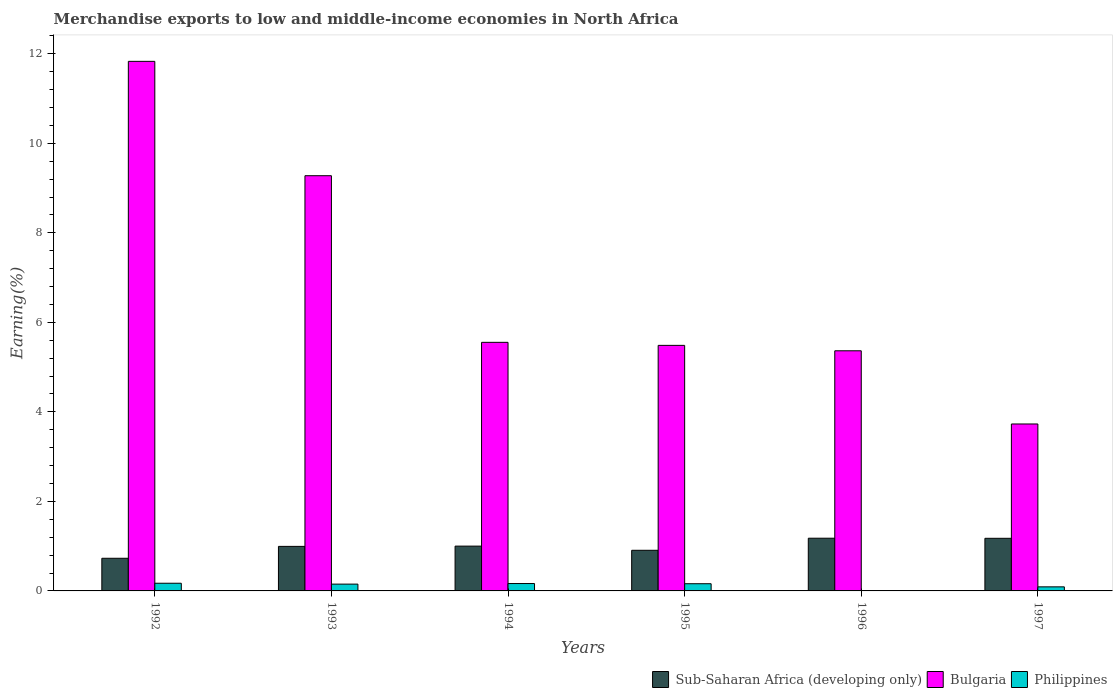How many different coloured bars are there?
Make the answer very short. 3. Are the number of bars on each tick of the X-axis equal?
Provide a short and direct response. Yes. What is the percentage of amount earned from merchandise exports in Bulgaria in 1996?
Offer a terse response. 5.36. Across all years, what is the maximum percentage of amount earned from merchandise exports in Bulgaria?
Your response must be concise. 11.83. Across all years, what is the minimum percentage of amount earned from merchandise exports in Sub-Saharan Africa (developing only)?
Offer a very short reply. 0.73. In which year was the percentage of amount earned from merchandise exports in Sub-Saharan Africa (developing only) maximum?
Your answer should be compact. 1996. In which year was the percentage of amount earned from merchandise exports in Bulgaria minimum?
Your response must be concise. 1997. What is the total percentage of amount earned from merchandise exports in Philippines in the graph?
Provide a succinct answer. 0.75. What is the difference between the percentage of amount earned from merchandise exports in Sub-Saharan Africa (developing only) in 1995 and that in 1997?
Give a very brief answer. -0.27. What is the difference between the percentage of amount earned from merchandise exports in Sub-Saharan Africa (developing only) in 1994 and the percentage of amount earned from merchandise exports in Philippines in 1995?
Provide a short and direct response. 0.84. What is the average percentage of amount earned from merchandise exports in Bulgaria per year?
Provide a succinct answer. 6.87. In the year 1996, what is the difference between the percentage of amount earned from merchandise exports in Sub-Saharan Africa (developing only) and percentage of amount earned from merchandise exports in Philippines?
Provide a short and direct response. 1.17. What is the ratio of the percentage of amount earned from merchandise exports in Philippines in 1992 to that in 1994?
Offer a very short reply. 1.04. Is the percentage of amount earned from merchandise exports in Bulgaria in 1992 less than that in 1995?
Your answer should be very brief. No. Is the difference between the percentage of amount earned from merchandise exports in Sub-Saharan Africa (developing only) in 1993 and 1995 greater than the difference between the percentage of amount earned from merchandise exports in Philippines in 1993 and 1995?
Offer a very short reply. Yes. What is the difference between the highest and the second highest percentage of amount earned from merchandise exports in Bulgaria?
Offer a very short reply. 2.55. What is the difference between the highest and the lowest percentage of amount earned from merchandise exports in Bulgaria?
Your answer should be compact. 8.1. Is the sum of the percentage of amount earned from merchandise exports in Philippines in 1996 and 1997 greater than the maximum percentage of amount earned from merchandise exports in Sub-Saharan Africa (developing only) across all years?
Keep it short and to the point. No. What does the 1st bar from the left in 1995 represents?
Ensure brevity in your answer.  Sub-Saharan Africa (developing only). What does the 3rd bar from the right in 1992 represents?
Provide a short and direct response. Sub-Saharan Africa (developing only). Is it the case that in every year, the sum of the percentage of amount earned from merchandise exports in Philippines and percentage of amount earned from merchandise exports in Bulgaria is greater than the percentage of amount earned from merchandise exports in Sub-Saharan Africa (developing only)?
Provide a short and direct response. Yes. How many bars are there?
Offer a terse response. 18. Are all the bars in the graph horizontal?
Offer a very short reply. No. What is the difference between two consecutive major ticks on the Y-axis?
Your answer should be compact. 2. Does the graph contain grids?
Your response must be concise. No. How are the legend labels stacked?
Offer a terse response. Horizontal. What is the title of the graph?
Your answer should be very brief. Merchandise exports to low and middle-income economies in North Africa. What is the label or title of the Y-axis?
Keep it short and to the point. Earning(%). What is the Earning(%) of Sub-Saharan Africa (developing only) in 1992?
Offer a terse response. 0.73. What is the Earning(%) of Bulgaria in 1992?
Your response must be concise. 11.83. What is the Earning(%) in Philippines in 1992?
Your response must be concise. 0.17. What is the Earning(%) of Sub-Saharan Africa (developing only) in 1993?
Give a very brief answer. 1. What is the Earning(%) of Bulgaria in 1993?
Offer a very short reply. 9.28. What is the Earning(%) of Philippines in 1993?
Your answer should be very brief. 0.15. What is the Earning(%) of Sub-Saharan Africa (developing only) in 1994?
Ensure brevity in your answer.  1. What is the Earning(%) of Bulgaria in 1994?
Your response must be concise. 5.55. What is the Earning(%) of Philippines in 1994?
Give a very brief answer. 0.16. What is the Earning(%) of Sub-Saharan Africa (developing only) in 1995?
Give a very brief answer. 0.91. What is the Earning(%) in Bulgaria in 1995?
Keep it short and to the point. 5.49. What is the Earning(%) in Philippines in 1995?
Your response must be concise. 0.16. What is the Earning(%) of Sub-Saharan Africa (developing only) in 1996?
Ensure brevity in your answer.  1.18. What is the Earning(%) of Bulgaria in 1996?
Your response must be concise. 5.36. What is the Earning(%) in Philippines in 1996?
Your answer should be very brief. 0. What is the Earning(%) in Sub-Saharan Africa (developing only) in 1997?
Make the answer very short. 1.18. What is the Earning(%) of Bulgaria in 1997?
Keep it short and to the point. 3.73. What is the Earning(%) in Philippines in 1997?
Give a very brief answer. 0.09. Across all years, what is the maximum Earning(%) of Sub-Saharan Africa (developing only)?
Provide a short and direct response. 1.18. Across all years, what is the maximum Earning(%) in Bulgaria?
Provide a succinct answer. 11.83. Across all years, what is the maximum Earning(%) in Philippines?
Your answer should be compact. 0.17. Across all years, what is the minimum Earning(%) in Sub-Saharan Africa (developing only)?
Offer a very short reply. 0.73. Across all years, what is the minimum Earning(%) of Bulgaria?
Make the answer very short. 3.73. Across all years, what is the minimum Earning(%) of Philippines?
Provide a succinct answer. 0. What is the total Earning(%) of Sub-Saharan Africa (developing only) in the graph?
Your answer should be very brief. 5.99. What is the total Earning(%) in Bulgaria in the graph?
Your response must be concise. 41.24. What is the total Earning(%) of Philippines in the graph?
Provide a short and direct response. 0.74. What is the difference between the Earning(%) in Sub-Saharan Africa (developing only) in 1992 and that in 1993?
Your answer should be very brief. -0.27. What is the difference between the Earning(%) of Bulgaria in 1992 and that in 1993?
Provide a short and direct response. 2.55. What is the difference between the Earning(%) in Philippines in 1992 and that in 1993?
Provide a short and direct response. 0.02. What is the difference between the Earning(%) in Sub-Saharan Africa (developing only) in 1992 and that in 1994?
Offer a very short reply. -0.27. What is the difference between the Earning(%) in Bulgaria in 1992 and that in 1994?
Make the answer very short. 6.28. What is the difference between the Earning(%) in Philippines in 1992 and that in 1994?
Make the answer very short. 0.01. What is the difference between the Earning(%) of Sub-Saharan Africa (developing only) in 1992 and that in 1995?
Keep it short and to the point. -0.18. What is the difference between the Earning(%) of Bulgaria in 1992 and that in 1995?
Keep it short and to the point. 6.35. What is the difference between the Earning(%) of Philippines in 1992 and that in 1995?
Your response must be concise. 0.01. What is the difference between the Earning(%) of Sub-Saharan Africa (developing only) in 1992 and that in 1996?
Provide a succinct answer. -0.45. What is the difference between the Earning(%) of Bulgaria in 1992 and that in 1996?
Offer a terse response. 6.47. What is the difference between the Earning(%) of Philippines in 1992 and that in 1996?
Keep it short and to the point. 0.17. What is the difference between the Earning(%) in Sub-Saharan Africa (developing only) in 1992 and that in 1997?
Your response must be concise. -0.45. What is the difference between the Earning(%) of Bulgaria in 1992 and that in 1997?
Provide a short and direct response. 8.1. What is the difference between the Earning(%) of Philippines in 1992 and that in 1997?
Your answer should be very brief. 0.08. What is the difference between the Earning(%) in Sub-Saharan Africa (developing only) in 1993 and that in 1994?
Offer a terse response. -0.01. What is the difference between the Earning(%) of Bulgaria in 1993 and that in 1994?
Give a very brief answer. 3.72. What is the difference between the Earning(%) of Philippines in 1993 and that in 1994?
Keep it short and to the point. -0.01. What is the difference between the Earning(%) in Sub-Saharan Africa (developing only) in 1993 and that in 1995?
Your answer should be very brief. 0.09. What is the difference between the Earning(%) of Bulgaria in 1993 and that in 1995?
Give a very brief answer. 3.79. What is the difference between the Earning(%) of Philippines in 1993 and that in 1995?
Ensure brevity in your answer.  -0.01. What is the difference between the Earning(%) in Sub-Saharan Africa (developing only) in 1993 and that in 1996?
Your answer should be very brief. -0.18. What is the difference between the Earning(%) in Bulgaria in 1993 and that in 1996?
Keep it short and to the point. 3.91. What is the difference between the Earning(%) of Philippines in 1993 and that in 1996?
Offer a very short reply. 0.15. What is the difference between the Earning(%) in Sub-Saharan Africa (developing only) in 1993 and that in 1997?
Your answer should be very brief. -0.18. What is the difference between the Earning(%) in Bulgaria in 1993 and that in 1997?
Ensure brevity in your answer.  5.55. What is the difference between the Earning(%) of Philippines in 1993 and that in 1997?
Your response must be concise. 0.06. What is the difference between the Earning(%) of Sub-Saharan Africa (developing only) in 1994 and that in 1995?
Provide a succinct answer. 0.09. What is the difference between the Earning(%) of Bulgaria in 1994 and that in 1995?
Make the answer very short. 0.07. What is the difference between the Earning(%) of Philippines in 1994 and that in 1995?
Ensure brevity in your answer.  0. What is the difference between the Earning(%) of Sub-Saharan Africa (developing only) in 1994 and that in 1996?
Your response must be concise. -0.18. What is the difference between the Earning(%) of Bulgaria in 1994 and that in 1996?
Your response must be concise. 0.19. What is the difference between the Earning(%) of Philippines in 1994 and that in 1996?
Provide a succinct answer. 0.16. What is the difference between the Earning(%) of Sub-Saharan Africa (developing only) in 1994 and that in 1997?
Give a very brief answer. -0.17. What is the difference between the Earning(%) of Bulgaria in 1994 and that in 1997?
Keep it short and to the point. 1.82. What is the difference between the Earning(%) in Philippines in 1994 and that in 1997?
Your response must be concise. 0.07. What is the difference between the Earning(%) in Sub-Saharan Africa (developing only) in 1995 and that in 1996?
Keep it short and to the point. -0.27. What is the difference between the Earning(%) in Bulgaria in 1995 and that in 1996?
Your answer should be very brief. 0.12. What is the difference between the Earning(%) of Philippines in 1995 and that in 1996?
Offer a terse response. 0.16. What is the difference between the Earning(%) of Sub-Saharan Africa (developing only) in 1995 and that in 1997?
Offer a terse response. -0.27. What is the difference between the Earning(%) in Bulgaria in 1995 and that in 1997?
Make the answer very short. 1.76. What is the difference between the Earning(%) of Philippines in 1995 and that in 1997?
Keep it short and to the point. 0.07. What is the difference between the Earning(%) in Sub-Saharan Africa (developing only) in 1996 and that in 1997?
Ensure brevity in your answer.  0. What is the difference between the Earning(%) in Bulgaria in 1996 and that in 1997?
Your response must be concise. 1.64. What is the difference between the Earning(%) in Philippines in 1996 and that in 1997?
Ensure brevity in your answer.  -0.09. What is the difference between the Earning(%) in Sub-Saharan Africa (developing only) in 1992 and the Earning(%) in Bulgaria in 1993?
Keep it short and to the point. -8.55. What is the difference between the Earning(%) in Sub-Saharan Africa (developing only) in 1992 and the Earning(%) in Philippines in 1993?
Your answer should be compact. 0.58. What is the difference between the Earning(%) in Bulgaria in 1992 and the Earning(%) in Philippines in 1993?
Your response must be concise. 11.68. What is the difference between the Earning(%) in Sub-Saharan Africa (developing only) in 1992 and the Earning(%) in Bulgaria in 1994?
Your answer should be compact. -4.82. What is the difference between the Earning(%) in Sub-Saharan Africa (developing only) in 1992 and the Earning(%) in Philippines in 1994?
Make the answer very short. 0.56. What is the difference between the Earning(%) of Bulgaria in 1992 and the Earning(%) of Philippines in 1994?
Ensure brevity in your answer.  11.67. What is the difference between the Earning(%) of Sub-Saharan Africa (developing only) in 1992 and the Earning(%) of Bulgaria in 1995?
Offer a very short reply. -4.76. What is the difference between the Earning(%) of Sub-Saharan Africa (developing only) in 1992 and the Earning(%) of Philippines in 1995?
Give a very brief answer. 0.57. What is the difference between the Earning(%) in Bulgaria in 1992 and the Earning(%) in Philippines in 1995?
Provide a succinct answer. 11.67. What is the difference between the Earning(%) of Sub-Saharan Africa (developing only) in 1992 and the Earning(%) of Bulgaria in 1996?
Offer a terse response. -4.64. What is the difference between the Earning(%) of Sub-Saharan Africa (developing only) in 1992 and the Earning(%) of Philippines in 1996?
Make the answer very short. 0.72. What is the difference between the Earning(%) of Bulgaria in 1992 and the Earning(%) of Philippines in 1996?
Your answer should be very brief. 11.83. What is the difference between the Earning(%) of Sub-Saharan Africa (developing only) in 1992 and the Earning(%) of Bulgaria in 1997?
Give a very brief answer. -3. What is the difference between the Earning(%) of Sub-Saharan Africa (developing only) in 1992 and the Earning(%) of Philippines in 1997?
Your response must be concise. 0.64. What is the difference between the Earning(%) in Bulgaria in 1992 and the Earning(%) in Philippines in 1997?
Provide a short and direct response. 11.74. What is the difference between the Earning(%) in Sub-Saharan Africa (developing only) in 1993 and the Earning(%) in Bulgaria in 1994?
Make the answer very short. -4.56. What is the difference between the Earning(%) of Sub-Saharan Africa (developing only) in 1993 and the Earning(%) of Philippines in 1994?
Ensure brevity in your answer.  0.83. What is the difference between the Earning(%) in Bulgaria in 1993 and the Earning(%) in Philippines in 1994?
Give a very brief answer. 9.11. What is the difference between the Earning(%) in Sub-Saharan Africa (developing only) in 1993 and the Earning(%) in Bulgaria in 1995?
Provide a succinct answer. -4.49. What is the difference between the Earning(%) in Sub-Saharan Africa (developing only) in 1993 and the Earning(%) in Philippines in 1995?
Provide a short and direct response. 0.83. What is the difference between the Earning(%) of Bulgaria in 1993 and the Earning(%) of Philippines in 1995?
Your answer should be compact. 9.12. What is the difference between the Earning(%) of Sub-Saharan Africa (developing only) in 1993 and the Earning(%) of Bulgaria in 1996?
Offer a very short reply. -4.37. What is the difference between the Earning(%) of Sub-Saharan Africa (developing only) in 1993 and the Earning(%) of Philippines in 1996?
Offer a terse response. 0.99. What is the difference between the Earning(%) in Bulgaria in 1993 and the Earning(%) in Philippines in 1996?
Provide a succinct answer. 9.27. What is the difference between the Earning(%) of Sub-Saharan Africa (developing only) in 1993 and the Earning(%) of Bulgaria in 1997?
Make the answer very short. -2.73. What is the difference between the Earning(%) of Sub-Saharan Africa (developing only) in 1993 and the Earning(%) of Philippines in 1997?
Keep it short and to the point. 0.9. What is the difference between the Earning(%) of Bulgaria in 1993 and the Earning(%) of Philippines in 1997?
Your answer should be compact. 9.19. What is the difference between the Earning(%) in Sub-Saharan Africa (developing only) in 1994 and the Earning(%) in Bulgaria in 1995?
Your answer should be very brief. -4.49. What is the difference between the Earning(%) of Sub-Saharan Africa (developing only) in 1994 and the Earning(%) of Philippines in 1995?
Offer a terse response. 0.84. What is the difference between the Earning(%) in Bulgaria in 1994 and the Earning(%) in Philippines in 1995?
Your response must be concise. 5.39. What is the difference between the Earning(%) in Sub-Saharan Africa (developing only) in 1994 and the Earning(%) in Bulgaria in 1996?
Keep it short and to the point. -4.36. What is the difference between the Earning(%) in Bulgaria in 1994 and the Earning(%) in Philippines in 1996?
Provide a short and direct response. 5.55. What is the difference between the Earning(%) of Sub-Saharan Africa (developing only) in 1994 and the Earning(%) of Bulgaria in 1997?
Your response must be concise. -2.73. What is the difference between the Earning(%) in Sub-Saharan Africa (developing only) in 1994 and the Earning(%) in Philippines in 1997?
Provide a succinct answer. 0.91. What is the difference between the Earning(%) of Bulgaria in 1994 and the Earning(%) of Philippines in 1997?
Your answer should be compact. 5.46. What is the difference between the Earning(%) in Sub-Saharan Africa (developing only) in 1995 and the Earning(%) in Bulgaria in 1996?
Your answer should be very brief. -4.46. What is the difference between the Earning(%) in Sub-Saharan Africa (developing only) in 1995 and the Earning(%) in Philippines in 1996?
Your response must be concise. 0.9. What is the difference between the Earning(%) of Bulgaria in 1995 and the Earning(%) of Philippines in 1996?
Your answer should be compact. 5.48. What is the difference between the Earning(%) of Sub-Saharan Africa (developing only) in 1995 and the Earning(%) of Bulgaria in 1997?
Your answer should be compact. -2.82. What is the difference between the Earning(%) in Sub-Saharan Africa (developing only) in 1995 and the Earning(%) in Philippines in 1997?
Offer a very short reply. 0.82. What is the difference between the Earning(%) of Bulgaria in 1995 and the Earning(%) of Philippines in 1997?
Ensure brevity in your answer.  5.4. What is the difference between the Earning(%) in Sub-Saharan Africa (developing only) in 1996 and the Earning(%) in Bulgaria in 1997?
Provide a succinct answer. -2.55. What is the difference between the Earning(%) in Sub-Saharan Africa (developing only) in 1996 and the Earning(%) in Philippines in 1997?
Provide a short and direct response. 1.09. What is the difference between the Earning(%) of Bulgaria in 1996 and the Earning(%) of Philippines in 1997?
Your answer should be very brief. 5.27. What is the average Earning(%) of Sub-Saharan Africa (developing only) per year?
Provide a short and direct response. 1. What is the average Earning(%) of Bulgaria per year?
Your response must be concise. 6.87. What is the average Earning(%) in Philippines per year?
Give a very brief answer. 0.12. In the year 1992, what is the difference between the Earning(%) in Sub-Saharan Africa (developing only) and Earning(%) in Bulgaria?
Your answer should be very brief. -11.1. In the year 1992, what is the difference between the Earning(%) in Sub-Saharan Africa (developing only) and Earning(%) in Philippines?
Your response must be concise. 0.56. In the year 1992, what is the difference between the Earning(%) in Bulgaria and Earning(%) in Philippines?
Provide a short and direct response. 11.66. In the year 1993, what is the difference between the Earning(%) of Sub-Saharan Africa (developing only) and Earning(%) of Bulgaria?
Keep it short and to the point. -8.28. In the year 1993, what is the difference between the Earning(%) of Sub-Saharan Africa (developing only) and Earning(%) of Philippines?
Offer a very short reply. 0.84. In the year 1993, what is the difference between the Earning(%) of Bulgaria and Earning(%) of Philippines?
Offer a terse response. 9.12. In the year 1994, what is the difference between the Earning(%) of Sub-Saharan Africa (developing only) and Earning(%) of Bulgaria?
Provide a short and direct response. -4.55. In the year 1994, what is the difference between the Earning(%) in Sub-Saharan Africa (developing only) and Earning(%) in Philippines?
Offer a very short reply. 0.84. In the year 1994, what is the difference between the Earning(%) in Bulgaria and Earning(%) in Philippines?
Make the answer very short. 5.39. In the year 1995, what is the difference between the Earning(%) in Sub-Saharan Africa (developing only) and Earning(%) in Bulgaria?
Give a very brief answer. -4.58. In the year 1995, what is the difference between the Earning(%) of Sub-Saharan Africa (developing only) and Earning(%) of Philippines?
Offer a very short reply. 0.75. In the year 1995, what is the difference between the Earning(%) in Bulgaria and Earning(%) in Philippines?
Give a very brief answer. 5.33. In the year 1996, what is the difference between the Earning(%) of Sub-Saharan Africa (developing only) and Earning(%) of Bulgaria?
Your answer should be very brief. -4.19. In the year 1996, what is the difference between the Earning(%) in Sub-Saharan Africa (developing only) and Earning(%) in Philippines?
Make the answer very short. 1.17. In the year 1996, what is the difference between the Earning(%) of Bulgaria and Earning(%) of Philippines?
Make the answer very short. 5.36. In the year 1997, what is the difference between the Earning(%) in Sub-Saharan Africa (developing only) and Earning(%) in Bulgaria?
Keep it short and to the point. -2.55. In the year 1997, what is the difference between the Earning(%) of Sub-Saharan Africa (developing only) and Earning(%) of Philippines?
Provide a short and direct response. 1.08. In the year 1997, what is the difference between the Earning(%) of Bulgaria and Earning(%) of Philippines?
Provide a succinct answer. 3.64. What is the ratio of the Earning(%) of Sub-Saharan Africa (developing only) in 1992 to that in 1993?
Your answer should be very brief. 0.73. What is the ratio of the Earning(%) of Bulgaria in 1992 to that in 1993?
Provide a short and direct response. 1.28. What is the ratio of the Earning(%) of Philippines in 1992 to that in 1993?
Offer a very short reply. 1.13. What is the ratio of the Earning(%) of Sub-Saharan Africa (developing only) in 1992 to that in 1994?
Offer a very short reply. 0.73. What is the ratio of the Earning(%) in Bulgaria in 1992 to that in 1994?
Provide a short and direct response. 2.13. What is the ratio of the Earning(%) in Philippines in 1992 to that in 1994?
Your answer should be very brief. 1.04. What is the ratio of the Earning(%) in Sub-Saharan Africa (developing only) in 1992 to that in 1995?
Ensure brevity in your answer.  0.8. What is the ratio of the Earning(%) of Bulgaria in 1992 to that in 1995?
Offer a very short reply. 2.16. What is the ratio of the Earning(%) in Philippines in 1992 to that in 1995?
Your answer should be very brief. 1.07. What is the ratio of the Earning(%) of Sub-Saharan Africa (developing only) in 1992 to that in 1996?
Provide a short and direct response. 0.62. What is the ratio of the Earning(%) in Bulgaria in 1992 to that in 1996?
Give a very brief answer. 2.21. What is the ratio of the Earning(%) in Philippines in 1992 to that in 1996?
Your response must be concise. 35.26. What is the ratio of the Earning(%) of Sub-Saharan Africa (developing only) in 1992 to that in 1997?
Give a very brief answer. 0.62. What is the ratio of the Earning(%) in Bulgaria in 1992 to that in 1997?
Your response must be concise. 3.17. What is the ratio of the Earning(%) in Philippines in 1992 to that in 1997?
Offer a very short reply. 1.88. What is the ratio of the Earning(%) of Bulgaria in 1993 to that in 1994?
Ensure brevity in your answer.  1.67. What is the ratio of the Earning(%) in Philippines in 1993 to that in 1994?
Provide a succinct answer. 0.92. What is the ratio of the Earning(%) in Sub-Saharan Africa (developing only) in 1993 to that in 1995?
Give a very brief answer. 1.1. What is the ratio of the Earning(%) in Bulgaria in 1993 to that in 1995?
Give a very brief answer. 1.69. What is the ratio of the Earning(%) in Philippines in 1993 to that in 1995?
Your response must be concise. 0.94. What is the ratio of the Earning(%) of Sub-Saharan Africa (developing only) in 1993 to that in 1996?
Offer a terse response. 0.85. What is the ratio of the Earning(%) in Bulgaria in 1993 to that in 1996?
Keep it short and to the point. 1.73. What is the ratio of the Earning(%) of Philippines in 1993 to that in 1996?
Your answer should be compact. 31.23. What is the ratio of the Earning(%) in Sub-Saharan Africa (developing only) in 1993 to that in 1997?
Provide a succinct answer. 0.85. What is the ratio of the Earning(%) of Bulgaria in 1993 to that in 1997?
Your answer should be very brief. 2.49. What is the ratio of the Earning(%) of Philippines in 1993 to that in 1997?
Offer a very short reply. 1.67. What is the ratio of the Earning(%) in Sub-Saharan Africa (developing only) in 1994 to that in 1995?
Provide a succinct answer. 1.1. What is the ratio of the Earning(%) in Bulgaria in 1994 to that in 1995?
Give a very brief answer. 1.01. What is the ratio of the Earning(%) in Philippines in 1994 to that in 1995?
Your response must be concise. 1.03. What is the ratio of the Earning(%) of Sub-Saharan Africa (developing only) in 1994 to that in 1996?
Your answer should be very brief. 0.85. What is the ratio of the Earning(%) of Bulgaria in 1994 to that in 1996?
Ensure brevity in your answer.  1.04. What is the ratio of the Earning(%) in Philippines in 1994 to that in 1996?
Keep it short and to the point. 33.9. What is the ratio of the Earning(%) in Sub-Saharan Africa (developing only) in 1994 to that in 1997?
Keep it short and to the point. 0.85. What is the ratio of the Earning(%) in Bulgaria in 1994 to that in 1997?
Your response must be concise. 1.49. What is the ratio of the Earning(%) in Philippines in 1994 to that in 1997?
Give a very brief answer. 1.81. What is the ratio of the Earning(%) in Sub-Saharan Africa (developing only) in 1995 to that in 1996?
Your response must be concise. 0.77. What is the ratio of the Earning(%) in Bulgaria in 1995 to that in 1996?
Ensure brevity in your answer.  1.02. What is the ratio of the Earning(%) of Philippines in 1995 to that in 1996?
Give a very brief answer. 33.07. What is the ratio of the Earning(%) of Sub-Saharan Africa (developing only) in 1995 to that in 1997?
Your response must be concise. 0.77. What is the ratio of the Earning(%) in Bulgaria in 1995 to that in 1997?
Your response must be concise. 1.47. What is the ratio of the Earning(%) of Philippines in 1995 to that in 1997?
Your response must be concise. 1.77. What is the ratio of the Earning(%) in Bulgaria in 1996 to that in 1997?
Keep it short and to the point. 1.44. What is the ratio of the Earning(%) in Philippines in 1996 to that in 1997?
Provide a succinct answer. 0.05. What is the difference between the highest and the second highest Earning(%) of Sub-Saharan Africa (developing only)?
Give a very brief answer. 0. What is the difference between the highest and the second highest Earning(%) in Bulgaria?
Keep it short and to the point. 2.55. What is the difference between the highest and the second highest Earning(%) in Philippines?
Give a very brief answer. 0.01. What is the difference between the highest and the lowest Earning(%) in Sub-Saharan Africa (developing only)?
Keep it short and to the point. 0.45. What is the difference between the highest and the lowest Earning(%) in Bulgaria?
Offer a very short reply. 8.1. What is the difference between the highest and the lowest Earning(%) of Philippines?
Offer a very short reply. 0.17. 